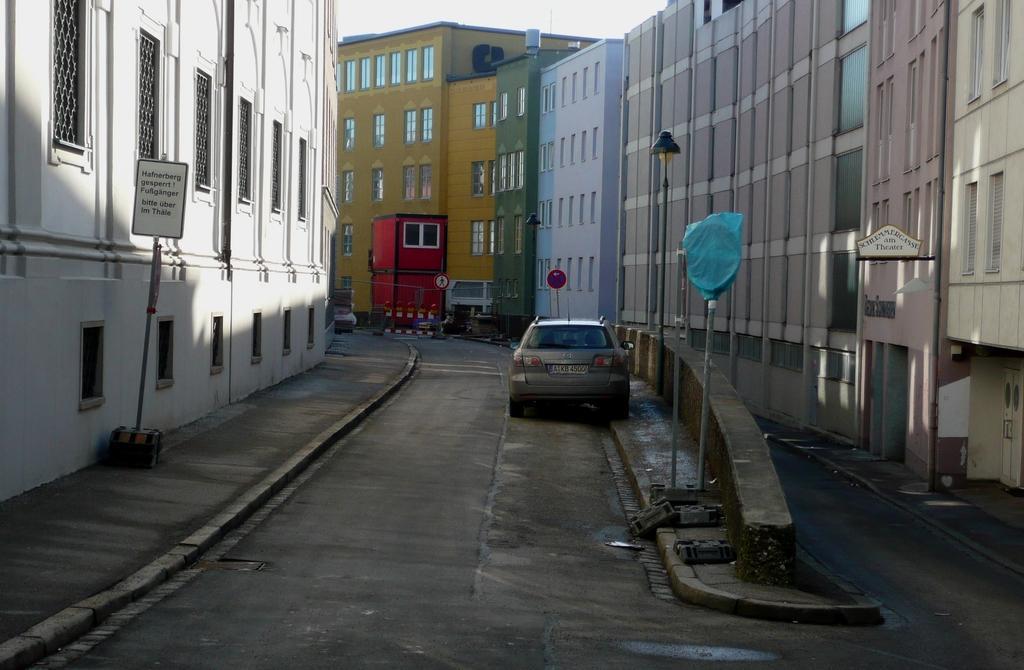Can you describe this image briefly? In the center of the image we can see a car on the road and on both sides of the image we can see the buildings. We can also see the safety barrier, fence and some informational board pole. We can also see the sign boards. Sky is also visible. 